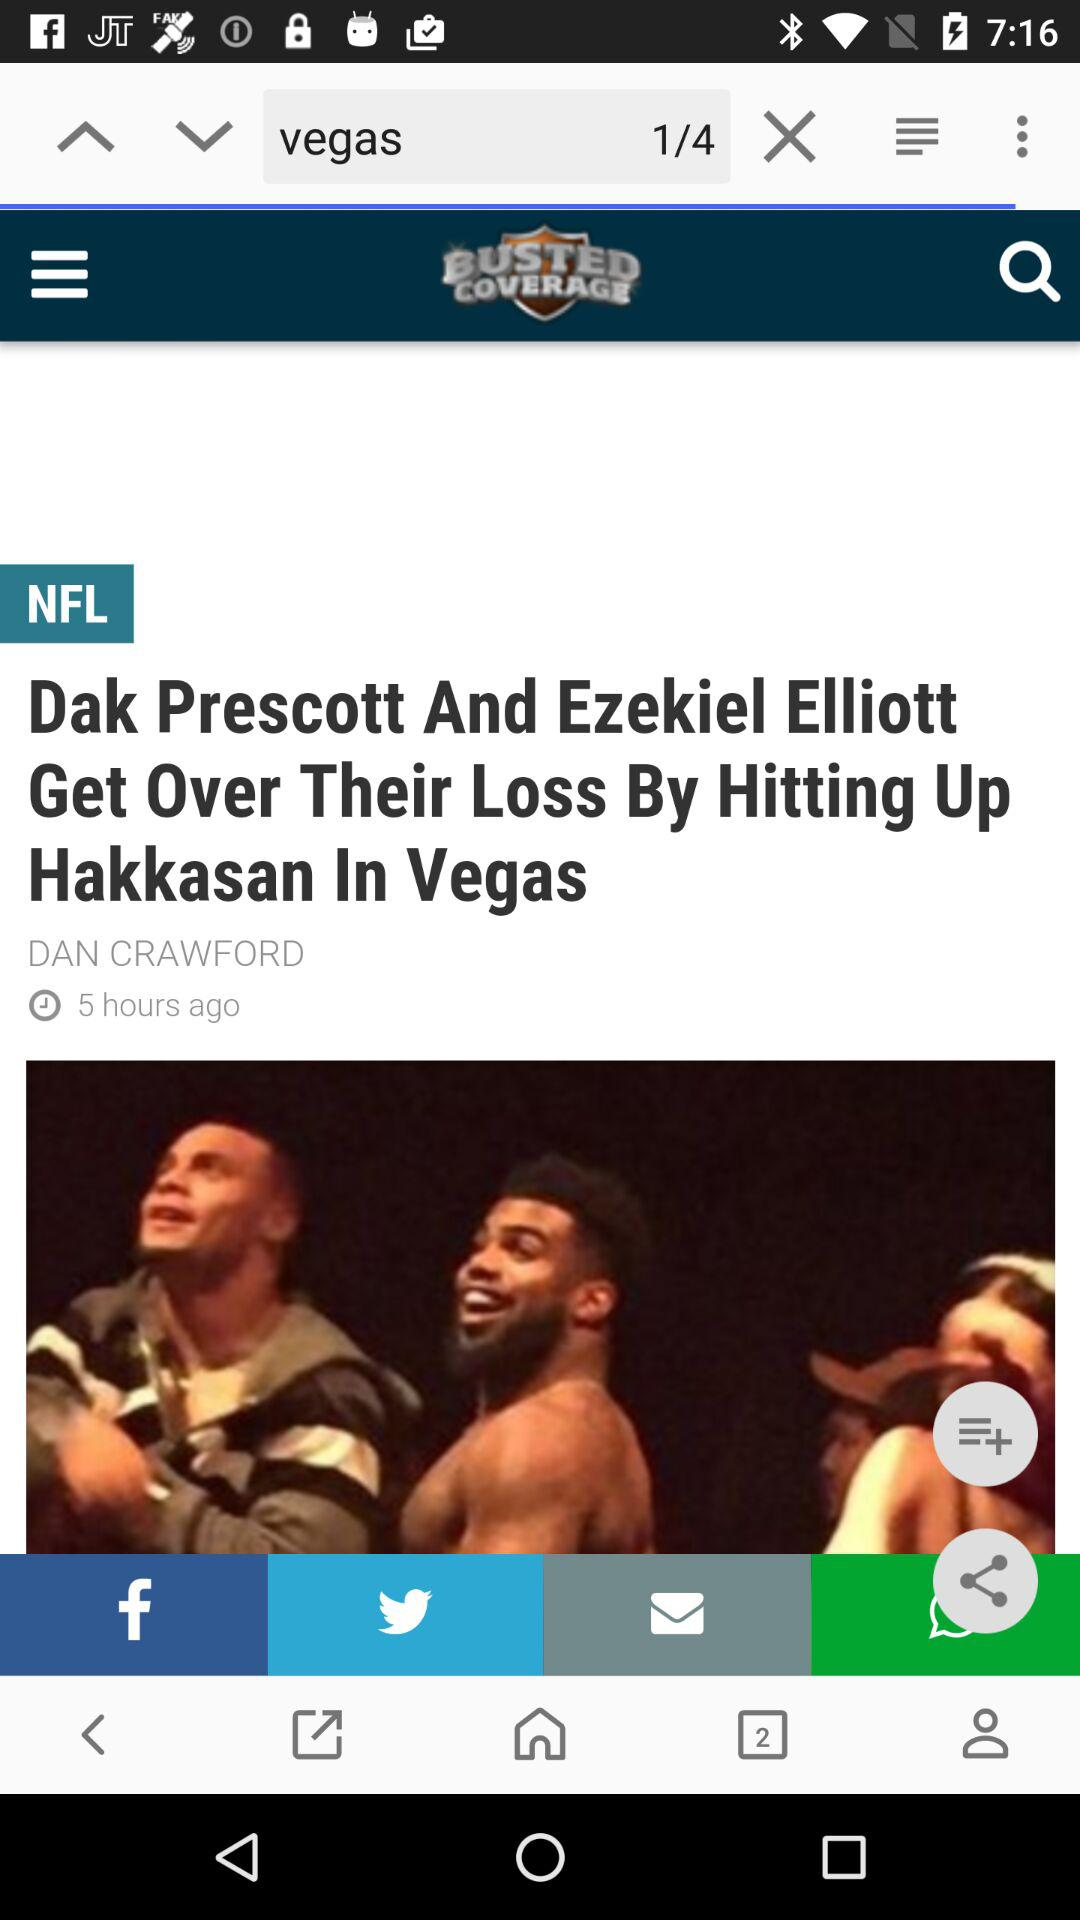How many hours ago was the post posted? The post was posted 5 hours ago. 